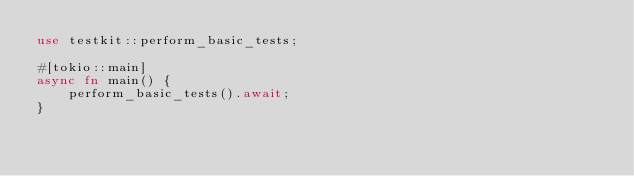Convert code to text. <code><loc_0><loc_0><loc_500><loc_500><_Rust_>use testkit::perform_basic_tests;

#[tokio::main]
async fn main() {
    perform_basic_tests().await;
}
</code> 